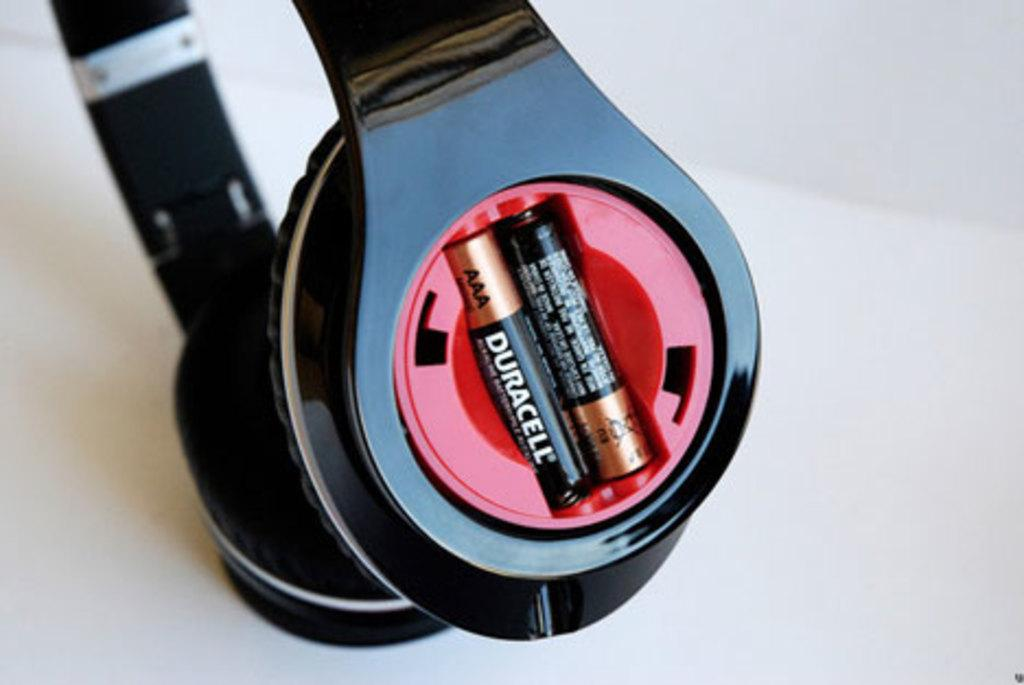<image>
Present a compact description of the photo's key features. Two AAA size Duracell batteries are installed in a pair of headphones. 